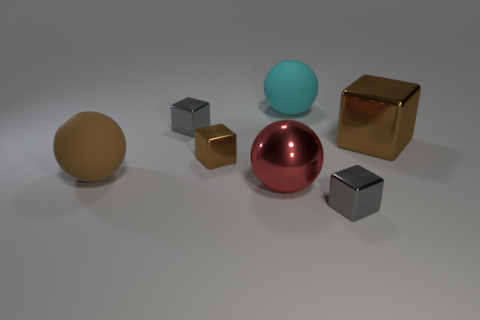There is a gray cube that is in front of the large matte ball in front of the small brown shiny object; how many brown rubber objects are behind it? 1 